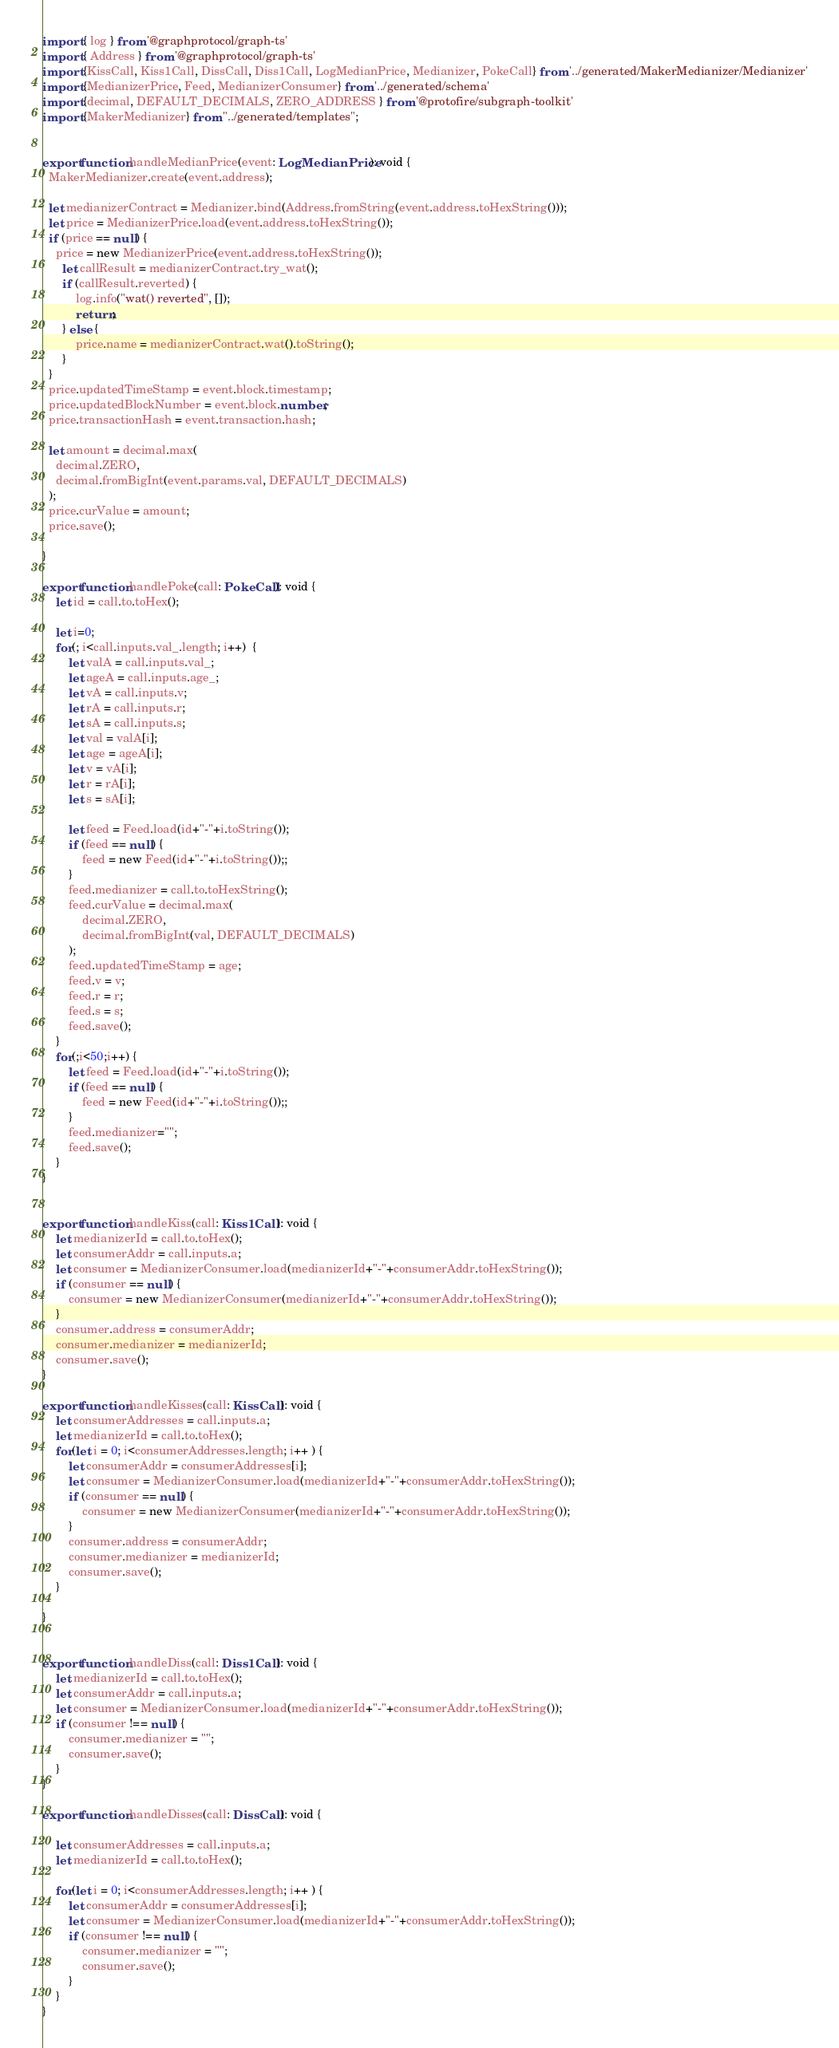<code> <loc_0><loc_0><loc_500><loc_500><_TypeScript_>import { log } from '@graphprotocol/graph-ts'
import { Address } from '@graphprotocol/graph-ts'
import {KissCall, Kiss1Call, DissCall, Diss1Call, LogMedianPrice, Medianizer, PokeCall} from '../generated/MakerMedianizer/Medianizer'
import {MedianizerPrice, Feed, MedianizerConsumer} from '../generated/schema'
import {decimal, DEFAULT_DECIMALS, ZERO_ADDRESS } from '@protofire/subgraph-toolkit'
import {MakerMedianizer} from "../generated/templates";


export function handleMedianPrice(event: LogMedianPrice): void {
  MakerMedianizer.create(event.address);

  let medianizerContract = Medianizer.bind(Address.fromString(event.address.toHexString()));
  let price = MedianizerPrice.load(event.address.toHexString());
  if (price == null) {
    price = new MedianizerPrice(event.address.toHexString());
      let callResult = medianizerContract.try_wat();
      if (callResult.reverted) {
          log.info("wat() reverted", []);
          return;
      } else {
          price.name = medianizerContract.wat().toString();
      }
  }
  price.updatedTimeStamp = event.block.timestamp;
  price.updatedBlockNumber = event.block.number;
  price.transactionHash = event.transaction.hash;

  let amount = decimal.max(
    decimal.ZERO,
    decimal.fromBigInt(event.params.val, DEFAULT_DECIMALS)
  );
  price.curValue = amount;
  price.save();

}

export function handlePoke(call: PokeCall): void {
    let id = call.to.toHex();

    let i=0;
    for(; i<call.inputs.val_.length; i++)  {
        let valA = call.inputs.val_;
        let ageA = call.inputs.age_;
        let vA = call.inputs.v;
        let rA = call.inputs.r;
        let sA = call.inputs.s;
        let val = valA[i];
        let age = ageA[i];
        let v = vA[i];
        let r = rA[i];
        let s = sA[i];

        let feed = Feed.load(id+"-"+i.toString());
        if (feed == null) {
            feed = new Feed(id+"-"+i.toString());;
        }
        feed.medianizer = call.to.toHexString();
        feed.curValue = decimal.max(
            decimal.ZERO,
            decimal.fromBigInt(val, DEFAULT_DECIMALS)
        );
        feed.updatedTimeStamp = age;
        feed.v = v;
        feed.r = r;
        feed.s = s;
        feed.save();
    }
    for(;i<50;i++) {
        let feed = Feed.load(id+"-"+i.toString());
        if (feed == null) {
            feed = new Feed(id+"-"+i.toString());;
        }
        feed.medianizer="";
        feed.save();
    }
}


export function handleKiss(call: Kiss1Call): void {
    let medianizerId = call.to.toHex();
    let consumerAddr = call.inputs.a;
    let consumer = MedianizerConsumer.load(medianizerId+"-"+consumerAddr.toHexString());
    if (consumer == null) {
        consumer = new MedianizerConsumer(medianizerId+"-"+consumerAddr.toHexString());
    }
    consumer.address = consumerAddr;
    consumer.medianizer = medianizerId;
    consumer.save();
}

export function handleKisses(call: KissCall): void {
    let consumerAddresses = call.inputs.a;
    let medianizerId = call.to.toHex();
    for(let i = 0; i<consumerAddresses.length; i++ ) {
        let consumerAddr = consumerAddresses[i];
        let consumer = MedianizerConsumer.load(medianizerId+"-"+consumerAddr.toHexString());
        if (consumer == null) {
            consumer = new MedianizerConsumer(medianizerId+"-"+consumerAddr.toHexString());
        }
        consumer.address = consumerAddr;
        consumer.medianizer = medianizerId;
        consumer.save();
    }

}


export function handleDiss(call: Diss1Call): void {
    let medianizerId = call.to.toHex();
    let consumerAddr = call.inputs.a;
    let consumer = MedianizerConsumer.load(medianizerId+"-"+consumerAddr.toHexString());
    if (consumer !== null) {
        consumer.medianizer = "";
        consumer.save();
    }
}

export function handleDisses(call: DissCall): void {

    let consumerAddresses = call.inputs.a;
    let medianizerId = call.to.toHex();

    for(let i = 0; i<consumerAddresses.length; i++ ) {
        let consumerAddr = consumerAddresses[i];
        let consumer = MedianizerConsumer.load(medianizerId+"-"+consumerAddr.toHexString());
        if (consumer !== null) {
            consumer.medianizer = "";
            consumer.save();
        }
    }
}
</code> 